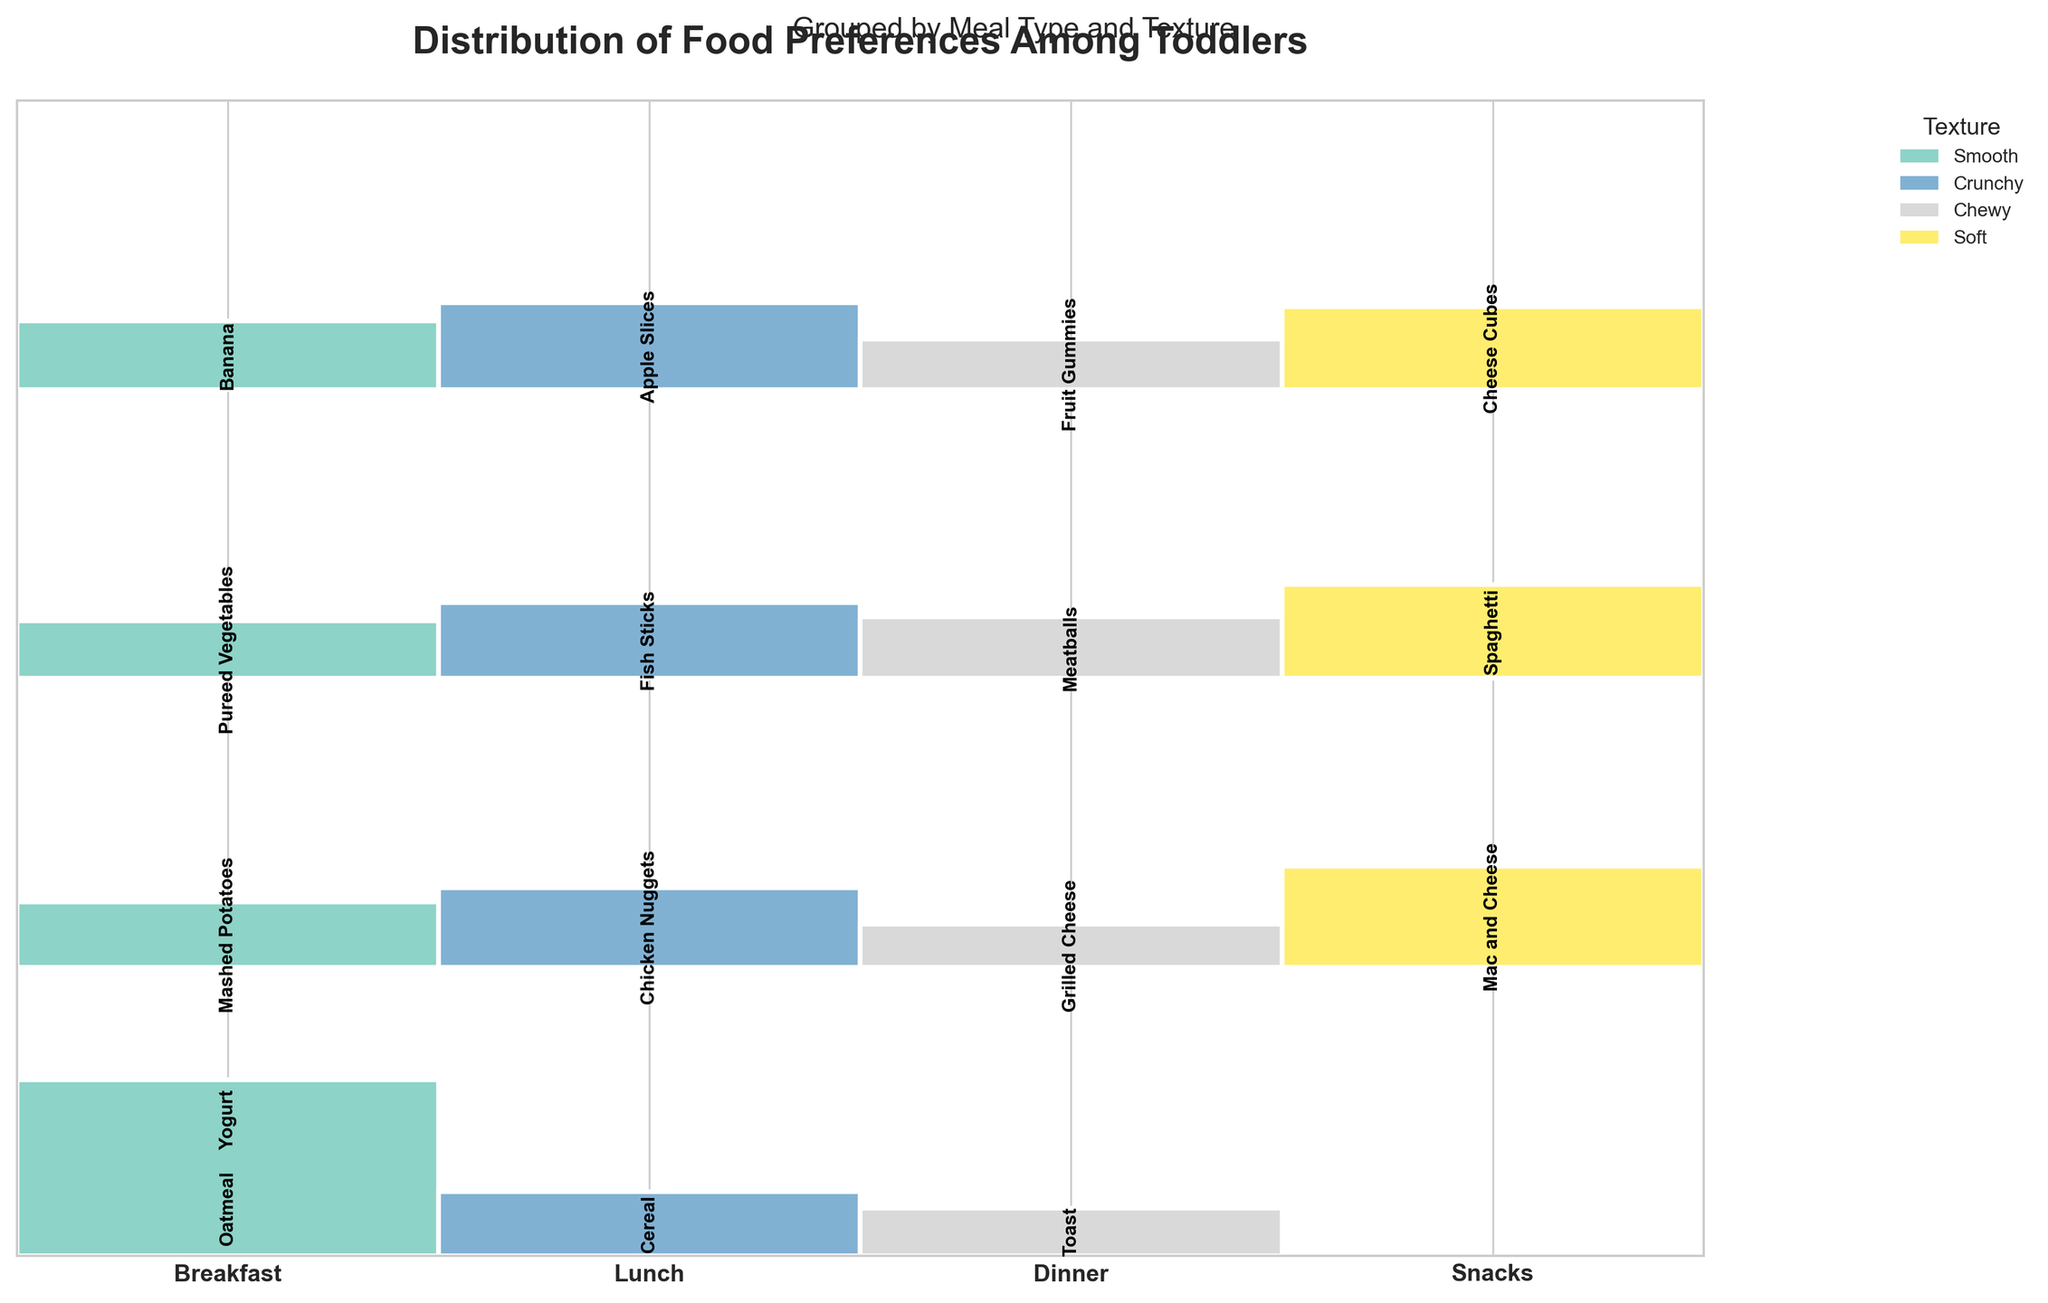Which meal type has the greatest variety of textures? To determine the meal type with the most variety of textures, look for the meal type that is divided into the most separate areas with different colors in the plot.
Answer: Lunch Which smooth-textured food did toddlers prefer the most for breakfast? Identify the region labeled "Breakfast" and check the smooth area. Look for the label with the highest count.
Answer: Oatmeal Which meal type has the least preference for chewy foods? Compare the height of the chewy texture areas in each meal type section to determine the smallest one.
Answer: Lunch Which meal type has the highest preference for crunchy foods? Look at the crunchy texture areas and identify which meal type section has the highest overall count.
Answer: Lunch How many food preferences are accounted for in the snacks meal type? Count all the labeled preferences within the "Snacks" area. Observing the figure, the preferences are "Apple Slices," "Banana," "Fruit Gummies," and "Cheese Cubes."
Answer: 4 Which texture has the least variety of preferences in snacks? Identify the texture within the "Snacks" section with the fewest distinct labeled foods.
Answer: Chewy Between breakfast and dinner, which meal type do toddlers prefer smooth textured food more? Compare the height of smooth texture areas in the "Breakfast" and "Dinner" sections.
Answer: Breakfast Which meal type has the highest total number of preferences? Sum up the counts for each preference in each meal type, and find the highest total. This involves comparing the total areas of different meal sections.
Answer: Breakfast Rank the meal types by the total number of chewy preferences from highest to lowest. Sum the counts of chewy preferences within each meal type section and then rank them from highest to lowest.
Answer: Breakfast, Dinner, Snacks, Lunch Is there any meal type where preferences are evenly distributed across different textures? Look for a meal type where the areas (counts) of different textures (color segments) are approximately equal in size.
Answer: No 